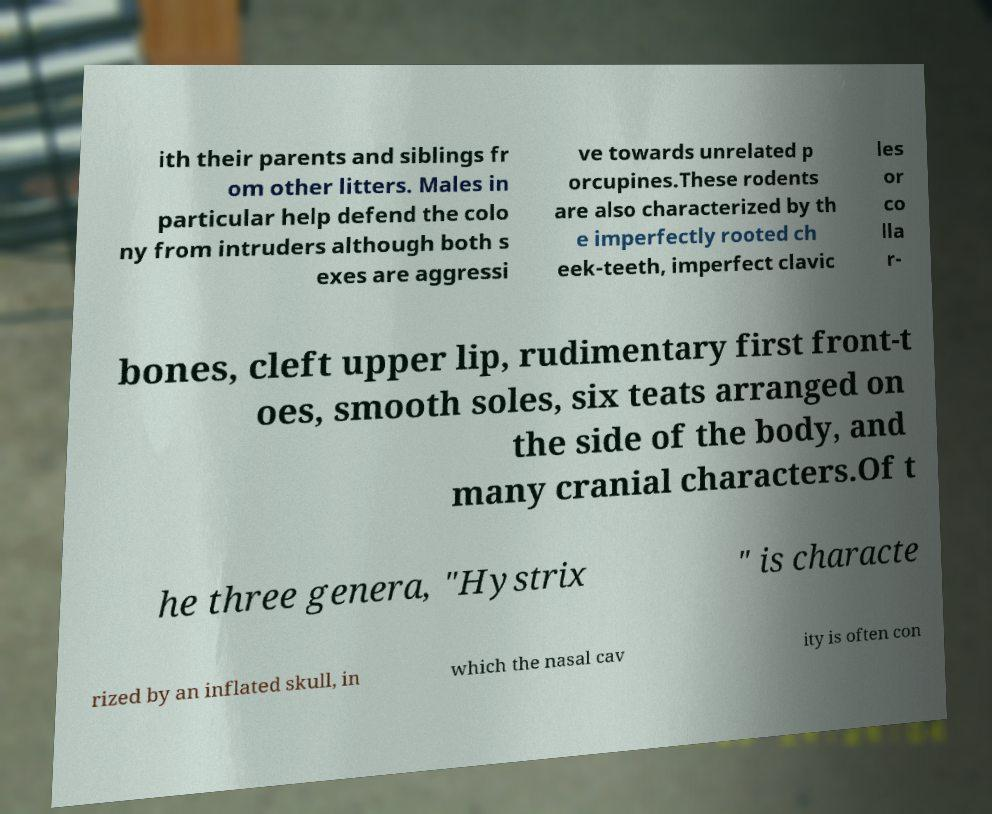For documentation purposes, I need the text within this image transcribed. Could you provide that? ith their parents and siblings fr om other litters. Males in particular help defend the colo ny from intruders although both s exes are aggressi ve towards unrelated p orcupines.These rodents are also characterized by th e imperfectly rooted ch eek-teeth, imperfect clavic les or co lla r- bones, cleft upper lip, rudimentary first front-t oes, smooth soles, six teats arranged on the side of the body, and many cranial characters.Of t he three genera, "Hystrix " is characte rized by an inflated skull, in which the nasal cav ity is often con 